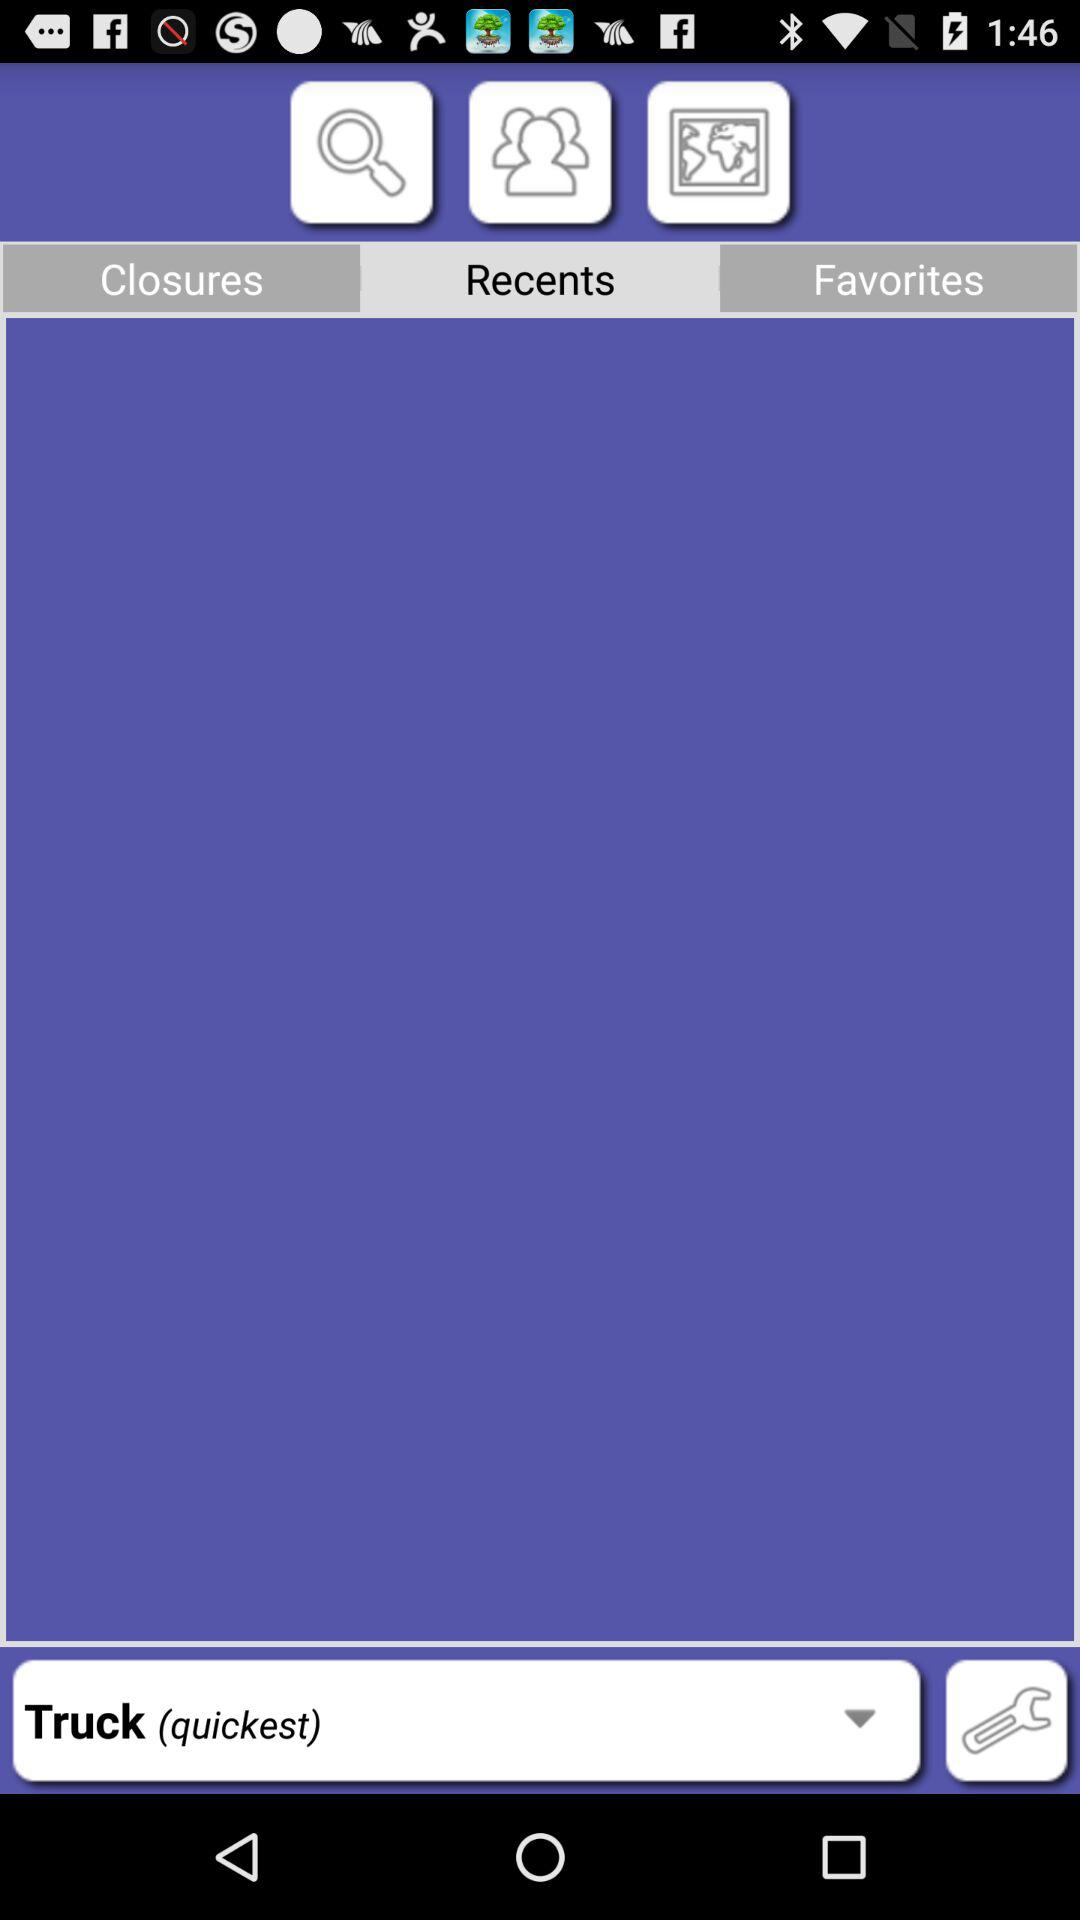Which tab is selected? The selected tab is "Recents". 